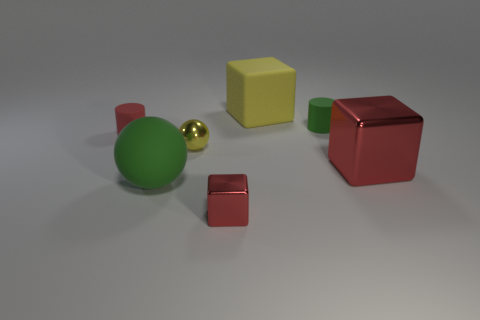Subtract 1 blocks. How many blocks are left? 2 Add 1 gray rubber cubes. How many objects exist? 8 Subtract all cylinders. How many objects are left? 5 Add 5 large green metal cubes. How many large green metal cubes exist? 5 Subtract 0 brown spheres. How many objects are left? 7 Subtract all tiny yellow metallic things. Subtract all matte cylinders. How many objects are left? 4 Add 5 big shiny blocks. How many big shiny blocks are left? 6 